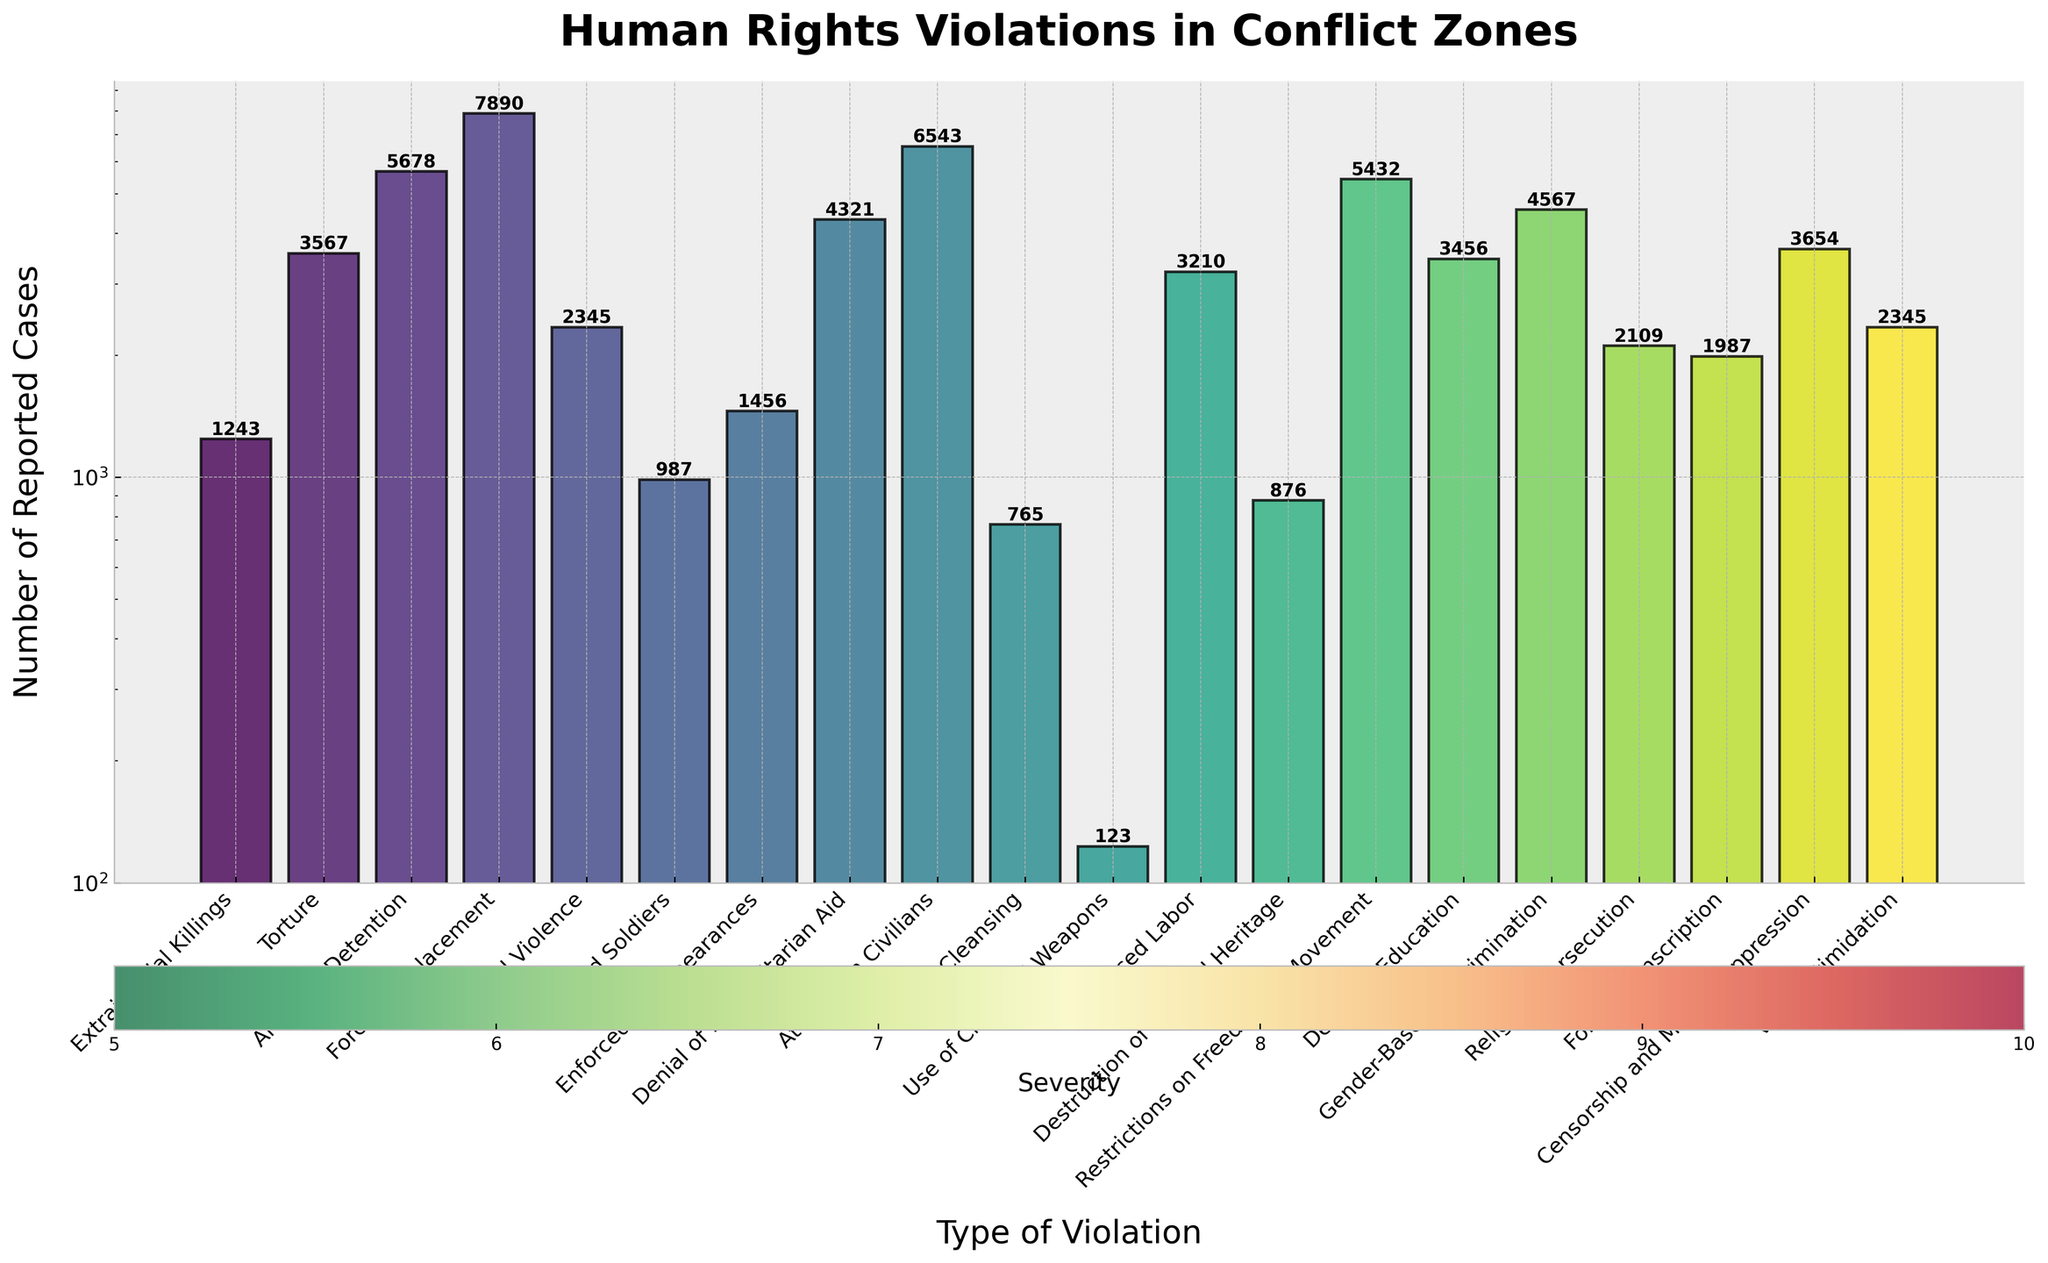What's the most reported type of human rights violation? By checking the heights of the bars, we see that the bar for "Arbitrary Detention" is the tallest, indicating that it has the highest number of reported cases.
Answer: Arbitrary Detention Which category has the highest severity among those with more than 4000 reported cases? Only "Torture," "Forced Displacement," and "Attacks on Civilians" have more than 4000 reported cases. Among them, the severity of "Attacks on Civilians" is the highest as it is 9, compared to 8 and 9 for the others.
Answer: Attacks on Civilians What is the total number of reported cases for human rights violations with a severity of 10? The types are "Extrajudicial Killings", "Ethnic Cleansing", and "Use of Chemical Weapons." The cases are 1243, 765, and 123 respectively. Summing these up: 1243 + 765 + 123 = 2131.
Answer: 2131 Which type of human rights violation has the lowest number of reported cases? By observing the heights of the bars, "Use of Chemical Weapons" has the shortest bar, indicating the lowest number of cases.
Answer: Use of Chemical Weapons Compare the reported cases of "Forced Labor" and "Gender-Based Discrimination." Which one has more reported cases? By comparing the heights of the bars for "Forced Labor" and "Gender-Based Discrimination," "Gender-Based Discrimination" has a taller bar, indicating more reported cases.
Answer: Gender-Based Discrimination What's the average number of reported cases for violations with a severity of 7? The types with severity 7 are "Denial of Humanitarian Aid," "Forced Labor," "Religious Persecution," and "Forced Conscription." Their reported cases are 4321, 3210, 2109, 1987 respectively. The average is (4321 + 3210 + 2109 + 1987) / 4 = 7909 / 4 = 1977.25
Answer: 1977.25 How does the visual representation indicate the severity of different types of violations? The severity is visually represented by the size of the scatter plot markers. Larger markers indicate higher severity. Additionally, the scatter plot uses a color gradient from green (low severity) to red (high severity).
Answer: Marker size and color Which type of violation has more reported cases: "Torture" or "Sexual Violence"? Comparing the heights of the bars for "Torture" and "Sexual Violence," the bar for "Torture" is taller.
Answer: Torture What is the combined number of reported cases for "Destruction of Cultural Heritage" and "Voter Intimidation"? The reported cases for "Destruction of Cultural Heritage" are 876, and for "Voter Intimidation" are 2345. Adding these gives 876 + 2345 = 3221.
Answer: 3221 